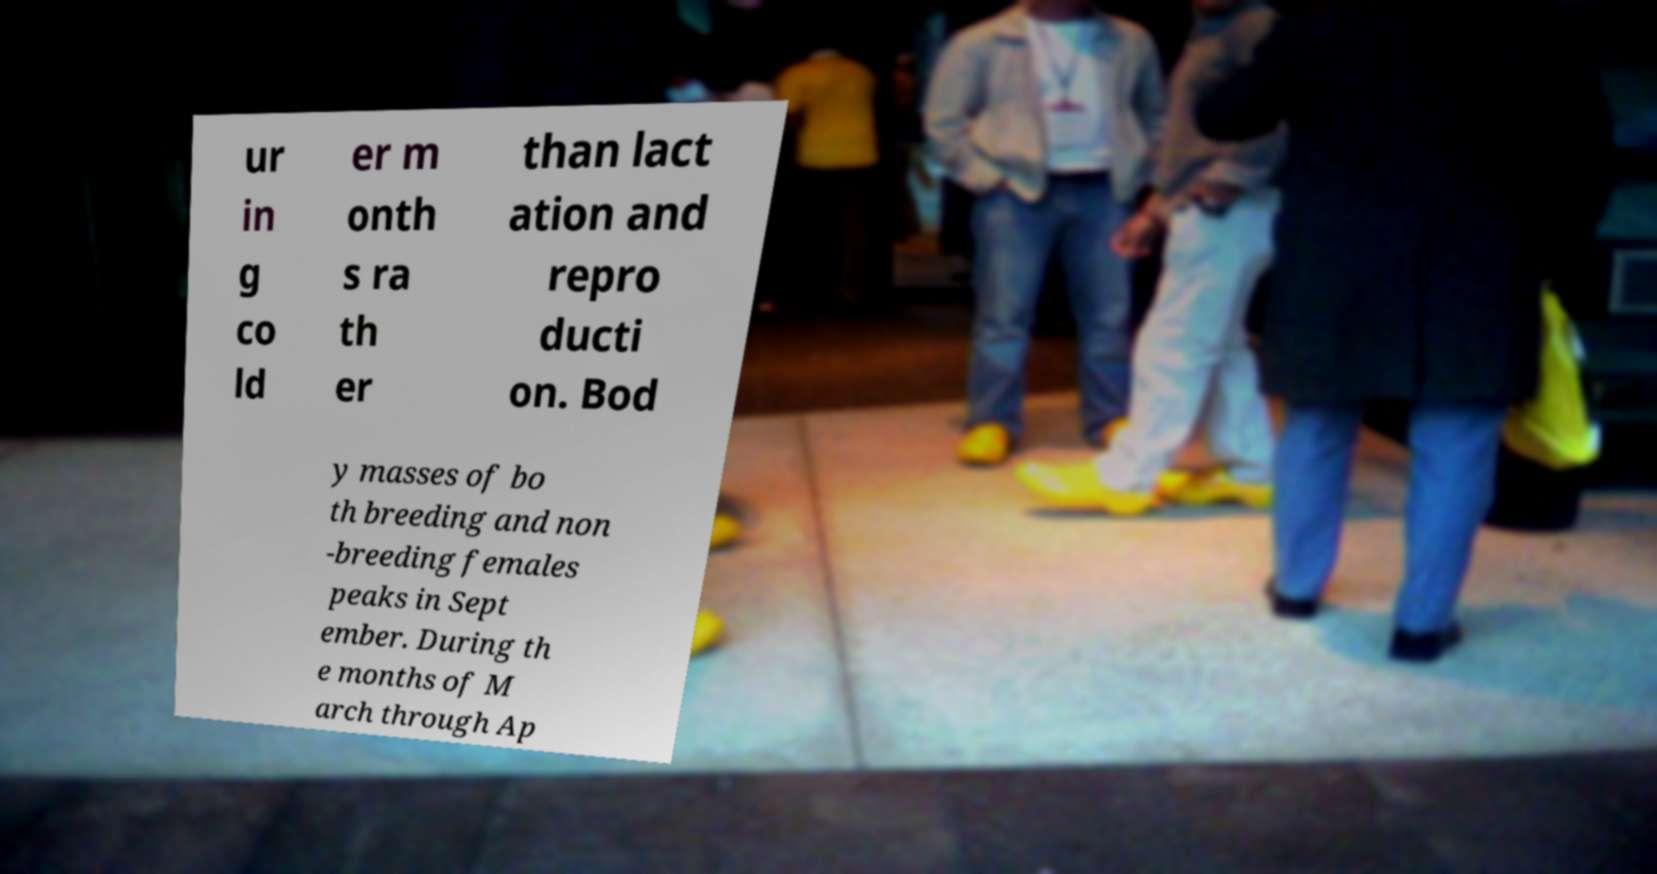Could you extract and type out the text from this image? ur in g co ld er m onth s ra th er than lact ation and repro ducti on. Bod y masses of bo th breeding and non -breeding females peaks in Sept ember. During th e months of M arch through Ap 